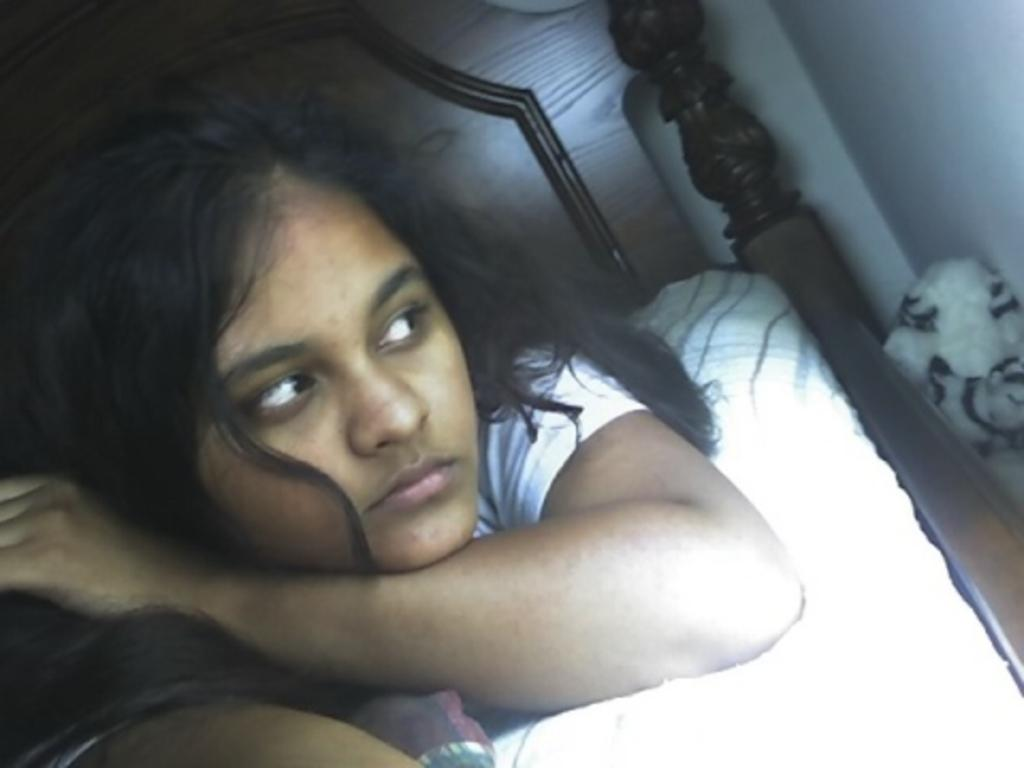What is the person in the image doing? The person is lying on a bed. What is the person wearing? The person is wearing a white t-shirt. What color is the bed-sheet on the bed? The bed-sheet is white. What color is the wall behind the bed? The wall is white. What type of bulb is hanging from the ceiling in the image? There is no bulb visible in the image. What offer is being made by the person on the bed? The image does not show any offers being made, as it only depicts a person lying on a bed. 